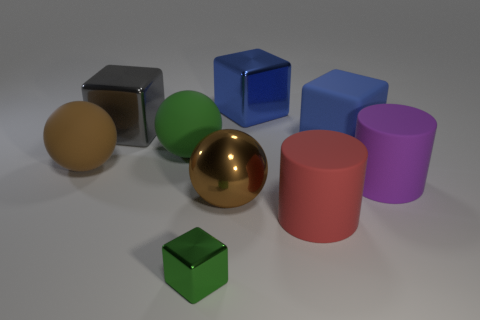Can you tell me which objects seem to be a pair based on their color? Yes, the two cylindrical objects appear to pair up based on their color. They are both featured in shades of pink, although one has a lighter hue and a different finish. The hues are similar, but the saturation levels differ, creating a perceivable pair in terms of color. 